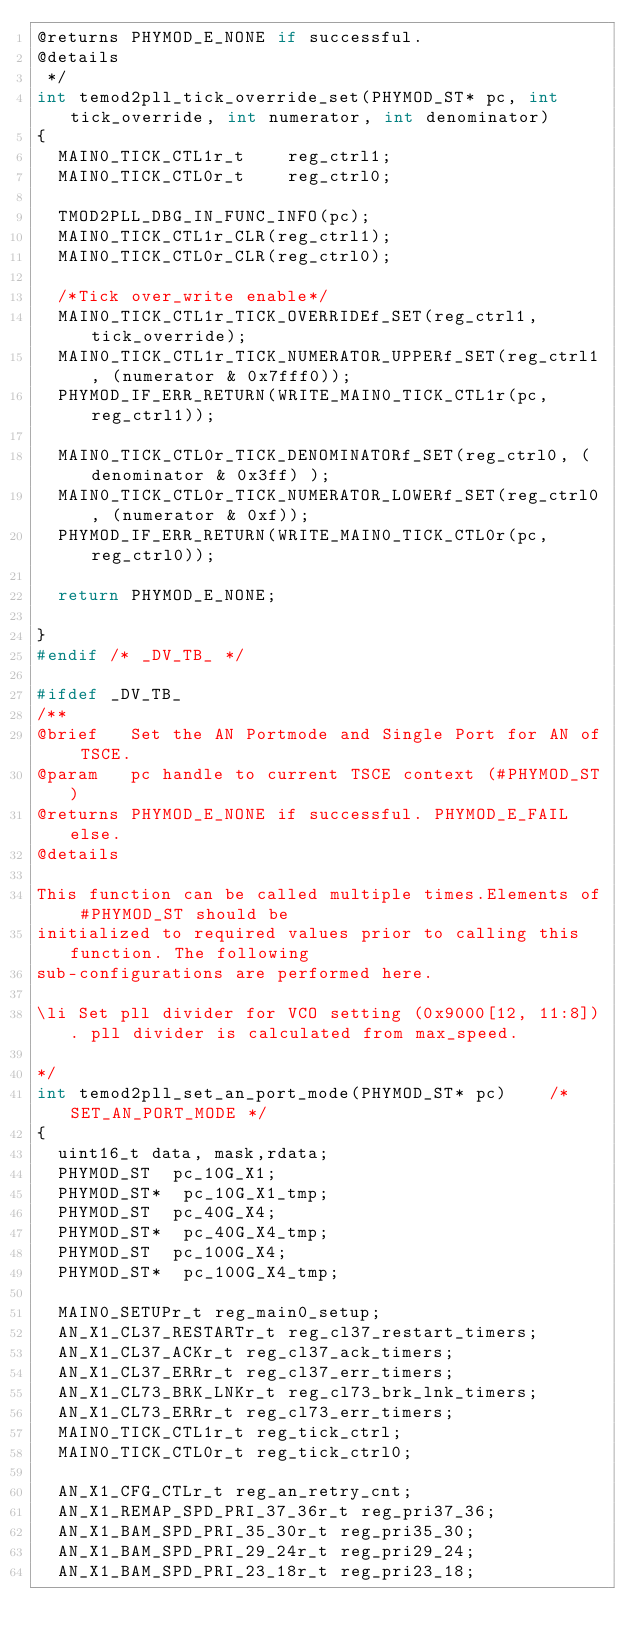Convert code to text. <code><loc_0><loc_0><loc_500><loc_500><_C_>@returns PHYMOD_E_NONE if successful.
@details
 */
int temod2pll_tick_override_set(PHYMOD_ST* pc, int tick_override, int numerator, int denominator)
{
  MAIN0_TICK_CTL1r_t    reg_ctrl1;
  MAIN0_TICK_CTL0r_t    reg_ctrl0;

  TMOD2PLL_DBG_IN_FUNC_INFO(pc);
  MAIN0_TICK_CTL1r_CLR(reg_ctrl1);
  MAIN0_TICK_CTL0r_CLR(reg_ctrl0);

  /*Tick over_write enable*/
  MAIN0_TICK_CTL1r_TICK_OVERRIDEf_SET(reg_ctrl1, tick_override);
  MAIN0_TICK_CTL1r_TICK_NUMERATOR_UPPERf_SET(reg_ctrl1, (numerator & 0x7fff0));
  PHYMOD_IF_ERR_RETURN(WRITE_MAIN0_TICK_CTL1r(pc, reg_ctrl1));

  MAIN0_TICK_CTL0r_TICK_DENOMINATORf_SET(reg_ctrl0, (denominator & 0x3ff) );
  MAIN0_TICK_CTL0r_TICK_NUMERATOR_LOWERf_SET(reg_ctrl0, (numerator & 0xf));
  PHYMOD_IF_ERR_RETURN(WRITE_MAIN0_TICK_CTL0r(pc, reg_ctrl0));

  return PHYMOD_E_NONE;

}
#endif /* _DV_TB_ */

#ifdef _DV_TB_
/**
@brief   Set the AN Portmode and Single Port for AN of TSCE.
@param   pc handle to current TSCE context (#PHYMOD_ST)
@returns PHYMOD_E_NONE if successful. PHYMOD_E_FAIL else.
@details

This function can be called multiple times.Elements of #PHYMOD_ST should be
initialized to required values prior to calling this function. The following
sub-configurations are performed here.

\li Set pll divider for VCO setting (0x9000[12, 11:8]). pll divider is calculated from max_speed.

*/
int temod2pll_set_an_port_mode(PHYMOD_ST* pc)    /* SET_AN_PORT_MODE */
{
  uint16_t data, mask,rdata;
  PHYMOD_ST  pc_10G_X1;
  PHYMOD_ST*  pc_10G_X1_tmp;
  PHYMOD_ST  pc_40G_X4;
  PHYMOD_ST*  pc_40G_X4_tmp;
  PHYMOD_ST  pc_100G_X4;
  PHYMOD_ST*  pc_100G_X4_tmp;

  MAIN0_SETUPr_t reg_main0_setup;
  AN_X1_CL37_RESTARTr_t reg_cl37_restart_timers;
  AN_X1_CL37_ACKr_t reg_cl37_ack_timers;
  AN_X1_CL37_ERRr_t reg_cl37_err_timers;
  AN_X1_CL73_BRK_LNKr_t reg_cl73_brk_lnk_timers;
  AN_X1_CL73_ERRr_t reg_cl73_err_timers;
  MAIN0_TICK_CTL1r_t reg_tick_ctrl;
  MAIN0_TICK_CTL0r_t reg_tick_ctrl0;

  AN_X1_CFG_CTLr_t reg_an_retry_cnt;
  AN_X1_REMAP_SPD_PRI_37_36r_t reg_pri37_36;
  AN_X1_BAM_SPD_PRI_35_30r_t reg_pri35_30;
  AN_X1_BAM_SPD_PRI_29_24r_t reg_pri29_24;
  AN_X1_BAM_SPD_PRI_23_18r_t reg_pri23_18;</code> 